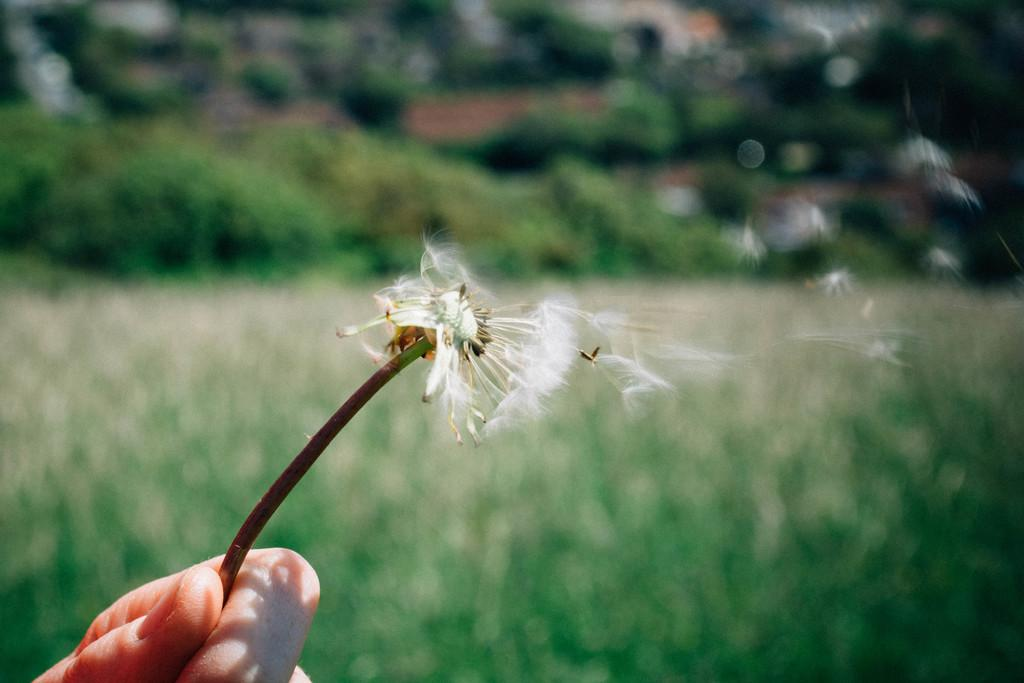Where was the image taken? The image was taken outdoors. What can be seen in the background of the image? There are many trees in the background of the image. What is present on the ground in the image? There are plants on the ground in the image. What is the person holding in their hand at the bottom of the image? The person is holding a flower in their hand at the bottom of the image. What type of thunder can be heard in the image? There is no sound present in the image, so it is not possible to determine if there is any thunder. 